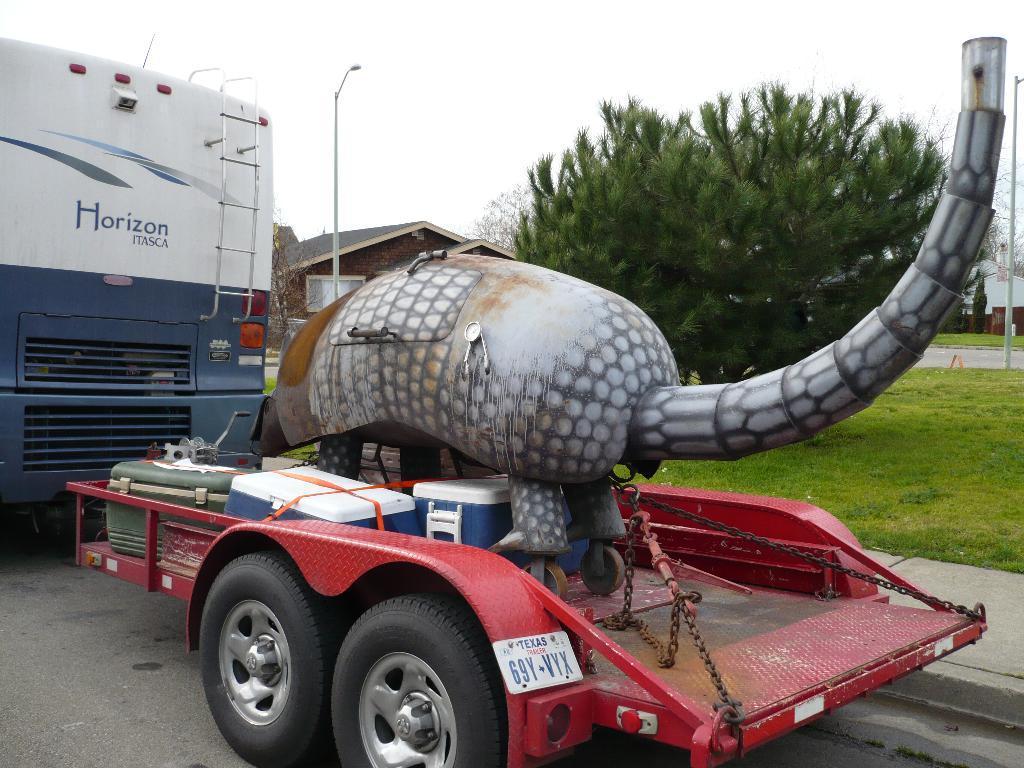In one or two sentences, can you explain what this image depicts? This is an outside. Here I can see two vehicles on the road. On the vehicle there are few boxes and an object which is in the shape of an animal. On the ground, I can see the grass. In the background there are some trees, buildings and poles. At the top of the image I can see the sky. 